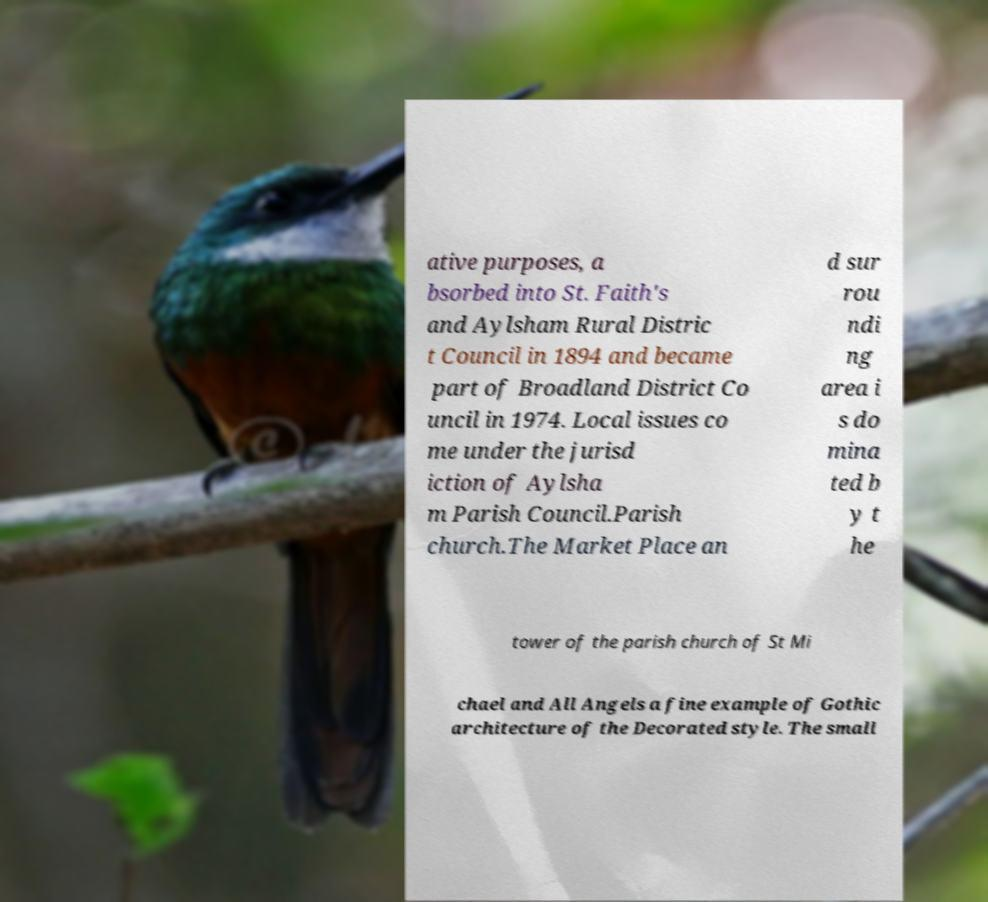Could you extract and type out the text from this image? ative purposes, a bsorbed into St. Faith's and Aylsham Rural Distric t Council in 1894 and became part of Broadland District Co uncil in 1974. Local issues co me under the jurisd iction of Aylsha m Parish Council.Parish church.The Market Place an d sur rou ndi ng area i s do mina ted b y t he tower of the parish church of St Mi chael and All Angels a fine example of Gothic architecture of the Decorated style. The small 